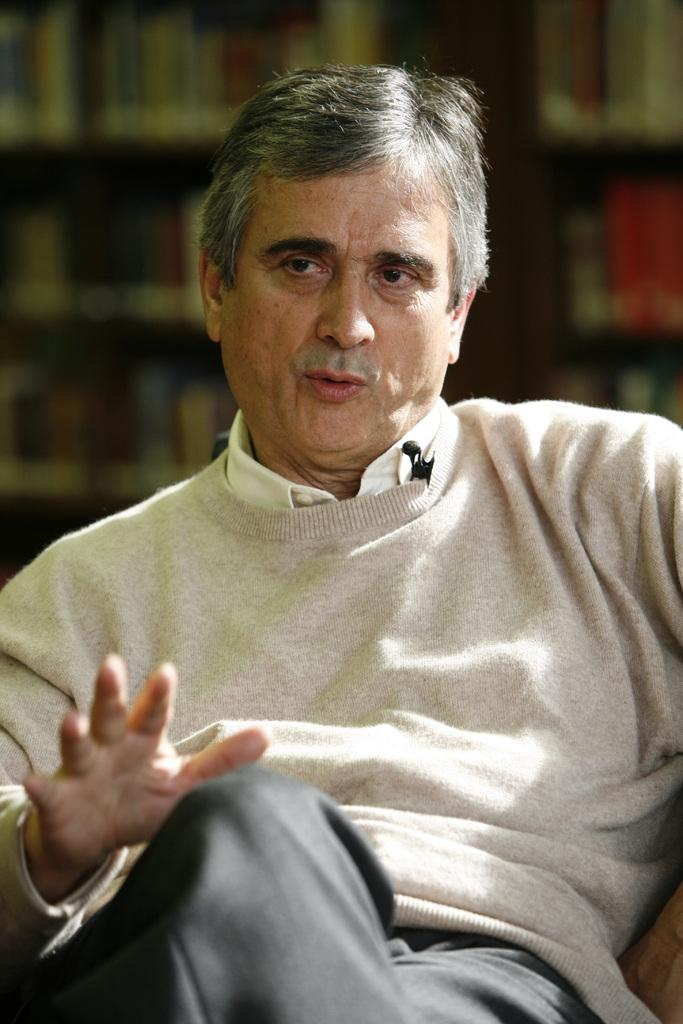What is the main subject of the image? There is a person sitting in the center of the image. Can you describe the background of the image? The background of the image is blurry. What chance does the person have of receiving a letter in the image? There is no indication of a letter or any mail-related activity in the image, so it cannot be determined from the image. 